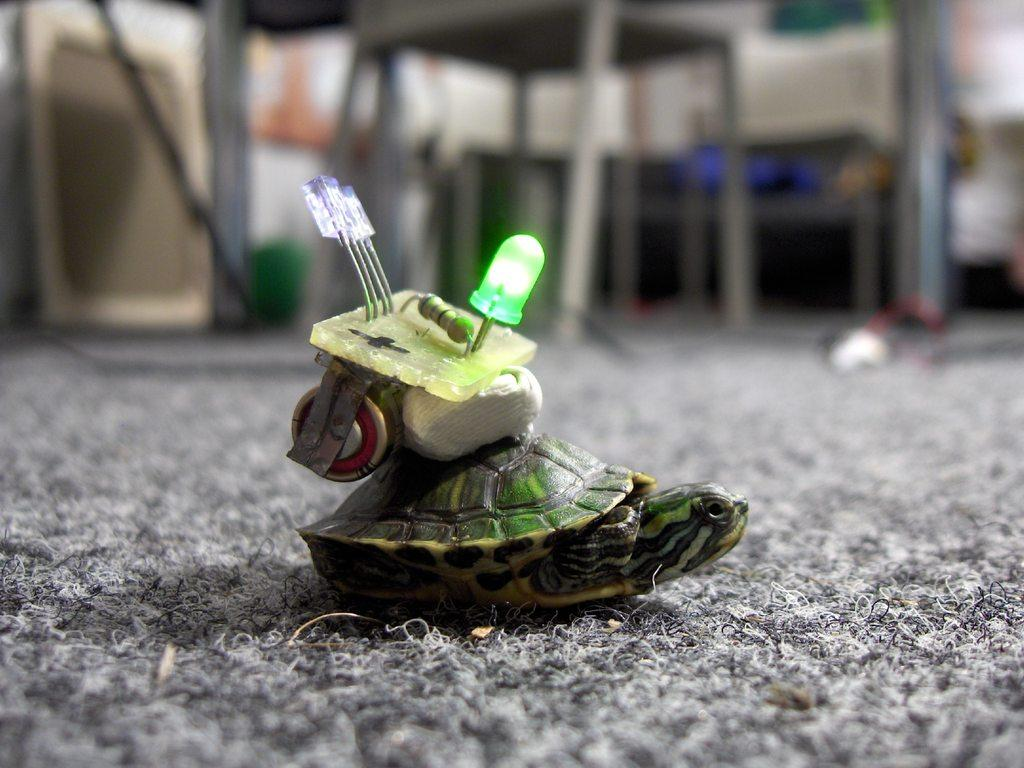What animal can be seen in the image? There is a turtle in the image. What is the color of the surface the turtle is on? The turtle is on an ash-colored surface. What is on top of the turtle? There are objects on the turtle. Can you describe the lighting in the image? There is light visible in the image. How would you describe the background of the image? The background of the image is blurred. What type of produce is growing on the branch in the image? There is no branch or produce present in the image. Where is the cave located in the image? There is no cave present in the image. 